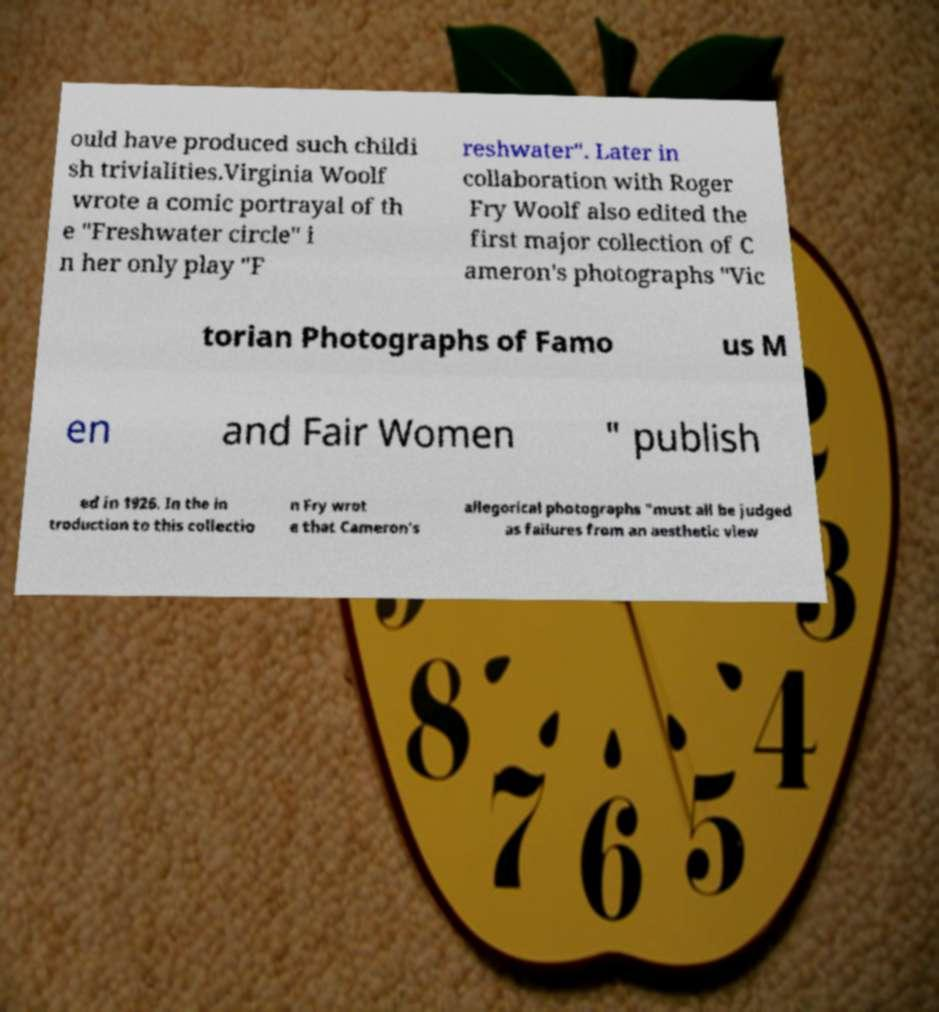There's text embedded in this image that I need extracted. Can you transcribe it verbatim? ould have produced such childi sh trivialities.Virginia Woolf wrote a comic portrayal of th e "Freshwater circle" i n her only play "F reshwater". Later in collaboration with Roger Fry Woolf also edited the first major collection of C ameron's photographs "Vic torian Photographs of Famo us M en and Fair Women " publish ed in 1926. In the in troduction to this collectio n Fry wrot e that Cameron's allegorical photographs "must all be judged as failures from an aesthetic view 